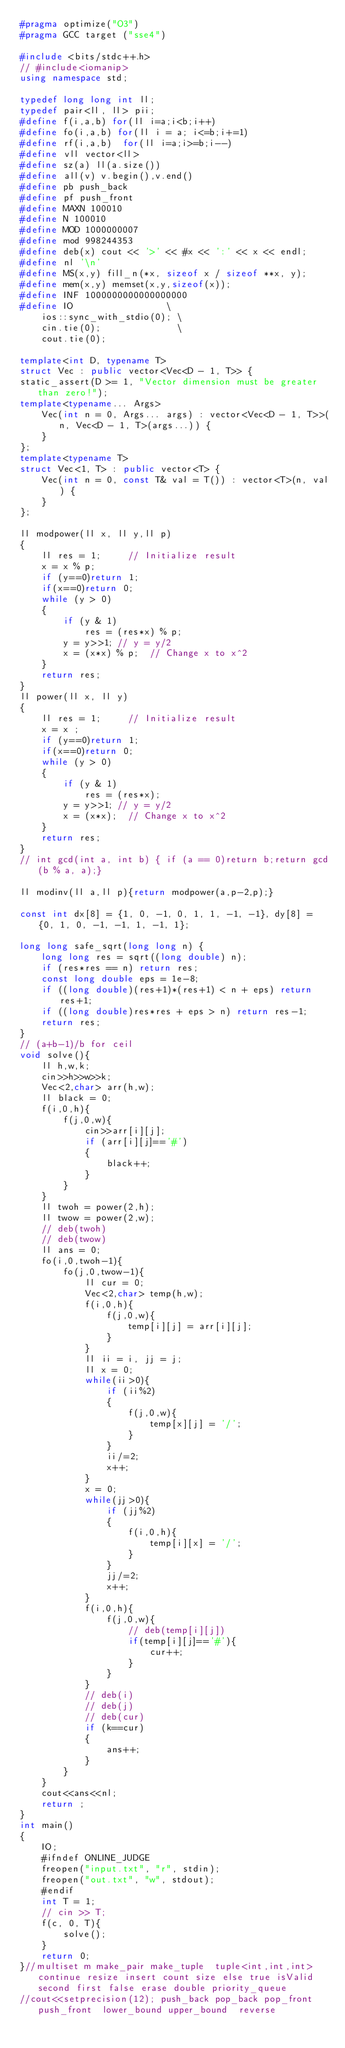Convert code to text. <code><loc_0><loc_0><loc_500><loc_500><_C++_>#pragma optimize("O3")
#pragma GCC target ("sse4")

#include <bits/stdc++.h>
// #include<iomanip>
using namespace std;

typedef long long int ll;
typedef pair<ll, ll> pii;
#define f(i,a,b) for(ll i=a;i<b;i++)
#define fo(i,a,b) for(ll i = a; i<=b;i+=1)
#define rf(i,a,b)  for(ll i=a;i>=b;i--)
#define vll vector<ll>
#define sz(a) ll(a.size())
#define all(v) v.begin(),v.end()
#define pb push_back
#define pf push_front 
#define MAXN 100010
#define N 100010
#define MOD 1000000007
#define mod 998244353
#define deb(x) cout << '>' << #x << ':' << x << endl;
#define nl '\n'
#define MS(x,y) fill_n(*x, sizeof x / sizeof **x, y);
#define mem(x,y) memset(x,y,sizeof(x));
#define INF 1000000000000000000
#define IO                 \
	ios::sync_with_stdio(0); \
	cin.tie(0);              \
	cout.tie(0);

template<int D, typename T>
struct Vec : public vector<Vec<D - 1, T>> {
static_assert(D >= 1, "Vector dimension must be greater than zero!");
template<typename... Args>
	Vec(int n = 0, Args... args) : vector<Vec<D - 1, T>>(n, Vec<D - 1, T>(args...)) {
	}
};
template<typename T>
struct Vec<1, T> : public vector<T> {
	Vec(int n = 0, const T& val = T()) : vector<T>(n, val) {
	}
};

ll modpower(ll x, ll y,ll p)
{
    ll res = 1;     // Initialize result
    x = x % p;
    if (y==0)return 1;
    if(x==0)return 0;
    while (y > 0)
    {
        if (y & 1)
            res = (res*x) % p;
        y = y>>1; // y = y/2
        x = (x*x) % p;  // Change x to x^2
    }
    return res;
}
ll power(ll x, ll y)
{
    ll res = 1;     // Initialize result
    x = x ;
    if (y==0)return 1;
    if(x==0)return 0;
    while (y > 0)
    {
        if (y & 1)
            res = (res*x);
        y = y>>1; // y = y/2
        x = (x*x);  // Change x to x^2
    }
    return res;
}
// int gcd(int a, int b) { if (a == 0)return b;return gcd(b % a, a);}

ll modinv(ll a,ll p){return modpower(a,p-2,p);}

const int dx[8] = {1, 0, -1, 0, 1, 1, -1, -1}, dy[8] = {0, 1, 0, -1, -1, 1, -1, 1};

long long safe_sqrt(long long n) {
    long long res = sqrt((long double) n);
    if (res*res == n) return res;
    const long double eps = 1e-8;
    if ((long double)(res+1)*(res+1) < n + eps) return res+1;
    if ((long double)res*res + eps > n) return res-1;
    return res;
}   
// (a+b-1)/b for ceil
void solve(){
    ll h,w,k;
    cin>>h>>w>>k;
    Vec<2,char> arr(h,w);
    ll black = 0;
    f(i,0,h){
        f(j,0,w){
            cin>>arr[i][j];
            if (arr[i][j]=='#')
            {
                black++;
            }
        }
    }
    ll twoh = power(2,h);
    ll twow = power(2,w);
    // deb(twoh)
    // deb(twow)
    ll ans = 0;
    fo(i,0,twoh-1){
        fo(j,0,twow-1){
            ll cur = 0;
            Vec<2,char> temp(h,w);
            f(i,0,h){
                f(j,0,w){
                    temp[i][j] = arr[i][j];
                }
            }
            ll ii = i, jj = j;
            ll x = 0;
            while(ii>0){
                if (ii%2)
                {
                    f(j,0,w){
                        temp[x][j] = '/';
                    }
                }
                ii/=2;
                x++;
            }
            x = 0;
            while(jj>0){
                if (jj%2)
                {
                    f(i,0,h){
                        temp[i][x] = '/';
                    }
                }
                jj/=2;
                x++;
            }
            f(i,0,h){
                f(j,0,w){
                    // deb(temp[i][j])
                    if(temp[i][j]=='#'){
                        cur++;
                    }
                }
            }
            // deb(i)
            // deb(j)
            // deb(cur)
            if (k==cur)
            {
                ans++;
            }
        }
    }
    cout<<ans<<nl;
    return ;
}
int main()
{
    IO;
    #ifndef ONLINE_JUDGE
    freopen("input.txt", "r", stdin);
    freopen("out.txt", "w", stdout);
    #endif
    int T = 1;
    // cin >> T;
    f(c, 0, T){
        solve();
    }
    return 0;
}//multiset m make_pair make_tuple  tuple<int,int,int> continue resize insert count size else true isValid second first false erase double priority_queue 
//cout<<setprecision(12); push_back pop_back pop_front push_front  lower_bound upper_bound  reverse</code> 